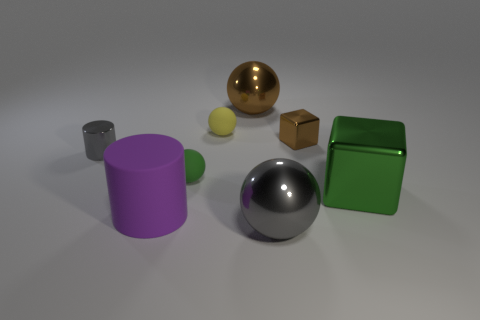Is the material of the cylinder behind the green rubber thing the same as the green thing that is on the right side of the brown metal ball?
Your answer should be compact. Yes. How many tiny things are either rubber things or purple objects?
Offer a terse response. 2. The big gray object that is the same material as the large green thing is what shape?
Your answer should be compact. Sphere. Is the number of small gray metallic things that are right of the small shiny cube less than the number of big gray matte spheres?
Keep it short and to the point. No. Does the large purple matte thing have the same shape as the yellow object?
Offer a terse response. No. How many metallic things are either tiny gray blocks or tiny yellow balls?
Give a very brief answer. 0. Is there a green matte sphere that has the same size as the gray metal cylinder?
Offer a terse response. Yes. What number of shiny cubes have the same size as the yellow object?
Give a very brief answer. 1. Does the gray shiny thing in front of the large cylinder have the same size as the brown thing to the right of the big brown metal thing?
Offer a terse response. No. What number of objects are either tiny green matte objects or brown objects right of the large brown shiny thing?
Your response must be concise. 2. 